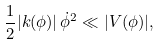Convert formula to latex. <formula><loc_0><loc_0><loc_500><loc_500>\frac { 1 } { 2 } | k ( \phi ) | \, \dot { \phi } ^ { 2 } \ll | V ( \phi ) | ,</formula> 